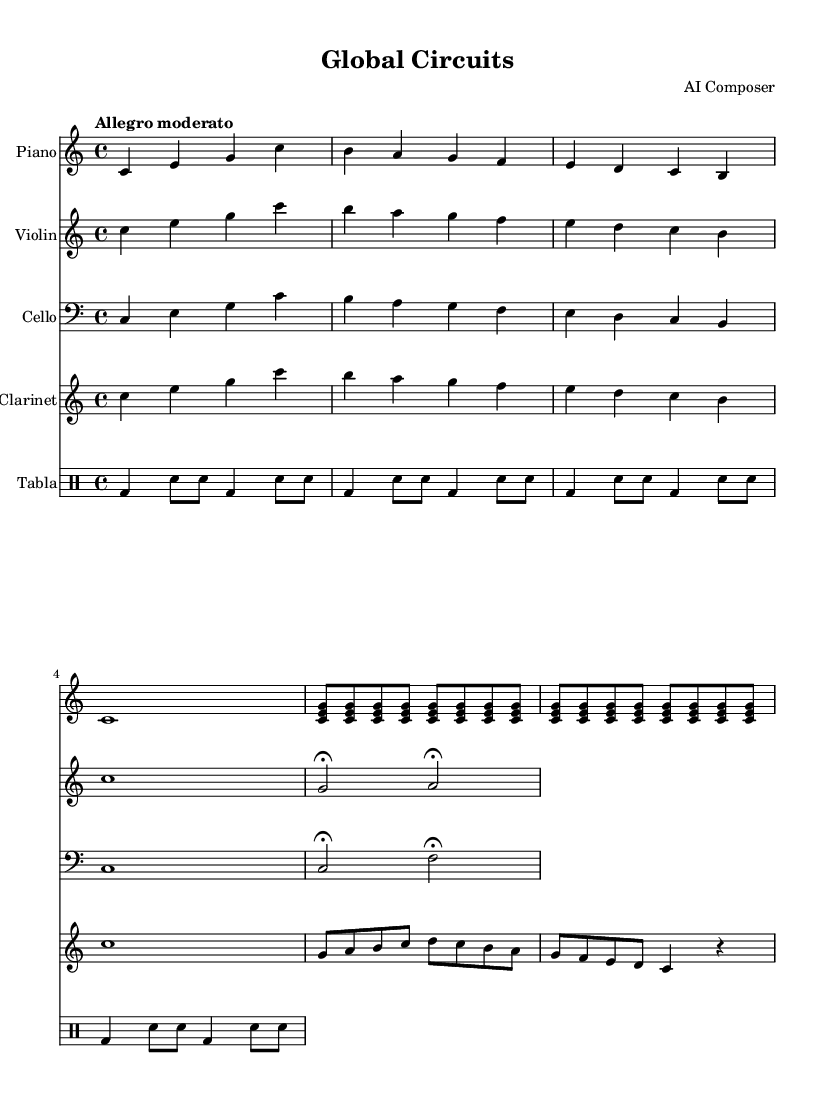What is the key signature of this music? The key signature is indicated at the beginning of the staff and shows that the piece is in C major, which has no sharps or flats.
Answer: C major What is the time signature of this piece? The time signature is shown at the beginning of the score, indicating four beats per measure, denoted by 4/4.
Answer: 4/4 What is the tempo marking for this composition? The tempo marking is found above the staff and reads "Allegro moderato," indicating a moderate-fast speed.
Answer: Allegro moderato Which instruments are included in this score? The score lists five instruments: Piano, Violin, Cello, Clarinet, and Tabla, as seen in the instrument name labels on each staff.
Answer: Piano, Violin, Cello, Clarinet, Tabla How many measures are present in the piano part? Counting the measures in the piano part reveals that there are 10 measures in total from the start to the end of the excerpt provided.
Answer: 10 What notable dynamic markings are present in the cello part? The cello part does not have specific dynamic markings listed, but the use of fermatas indicates moments of sustained tone, which draw attention to those notes.
Answer: Fermata What rhythmic pattern is used for the tabla? The rhythmic pattern in the tabla part consists of a repeating sequence of bass and snare drum hits arranged in a consistent 4/4 rhythm, contributing to the piece's overall texture.
Answer: Bass and snare pattern 